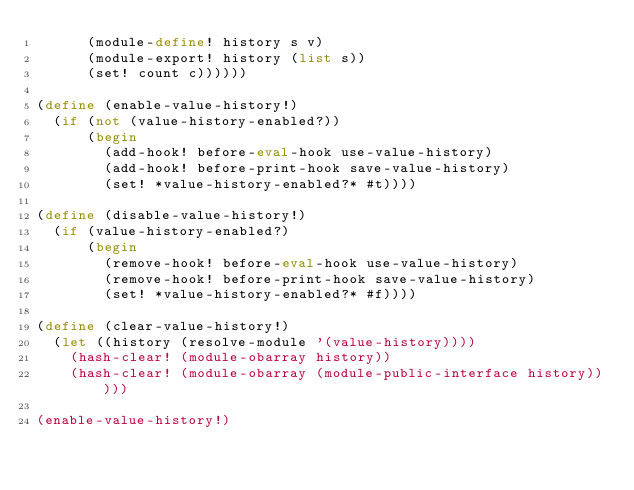<code> <loc_0><loc_0><loc_500><loc_500><_Scheme_>	    (module-define! history s v)
	    (module-export! history (list s))
	    (set! count c))))))

(define (enable-value-history!)
  (if (not (value-history-enabled?))
      (begin
        (add-hook! before-eval-hook use-value-history)
        (add-hook! before-print-hook save-value-history)
        (set! *value-history-enabled?* #t))))

(define (disable-value-history!)
  (if (value-history-enabled?)
      (begin
        (remove-hook! before-eval-hook use-value-history)
        (remove-hook! before-print-hook save-value-history)
        (set! *value-history-enabled?* #f))))

(define (clear-value-history!)
  (let ((history (resolve-module '(value-history))))
    (hash-clear! (module-obarray history))
    (hash-clear! (module-obarray (module-public-interface history)))))

(enable-value-history!)
</code> 